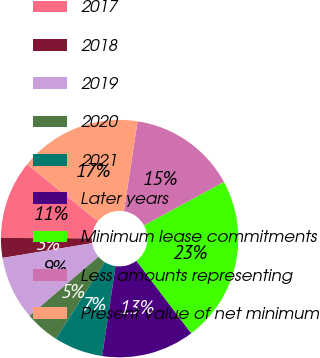<chart> <loc_0><loc_0><loc_500><loc_500><pie_chart><fcel>2017<fcel>2018<fcel>2019<fcel>2020<fcel>2021<fcel>Later years<fcel>Minimum lease commitments<fcel>Less amounts representing<fcel>Present value of net minimum<nl><fcel>10.67%<fcel>2.7%<fcel>8.68%<fcel>4.69%<fcel>6.68%<fcel>12.66%<fcel>22.62%<fcel>14.65%<fcel>16.65%<nl></chart> 